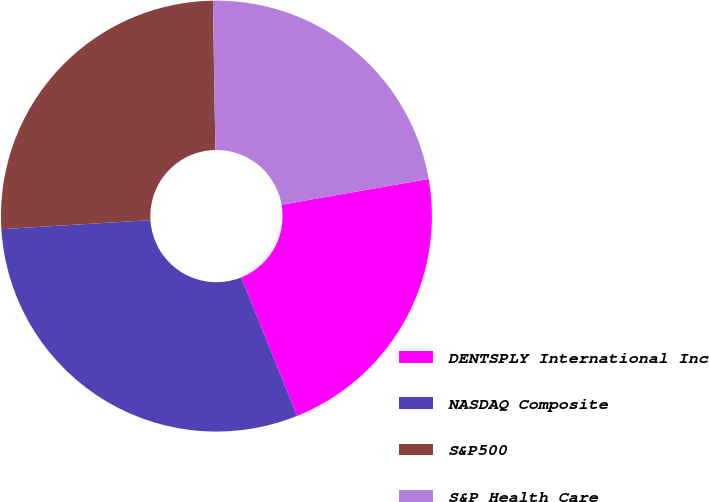<chart> <loc_0><loc_0><loc_500><loc_500><pie_chart><fcel>DENTSPLY International Inc<fcel>NASDAQ Composite<fcel>S&P500<fcel>S&P Health Care<nl><fcel>21.65%<fcel>30.14%<fcel>25.71%<fcel>22.5%<nl></chart> 